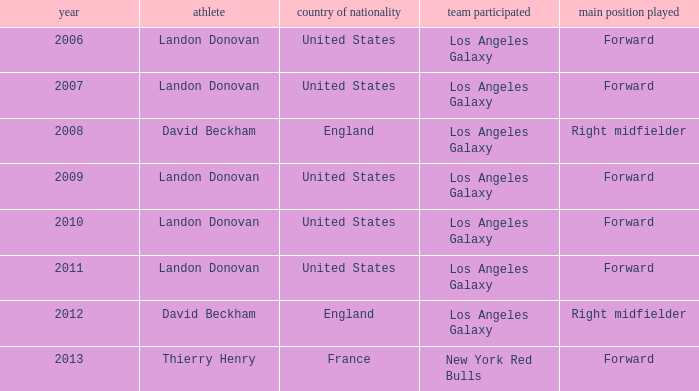What is the sum of all the years that Landon Donovan won the ESPY award? 5.0. 